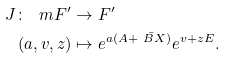Convert formula to latex. <formula><loc_0><loc_0><loc_500><loc_500>J \colon \ m F ^ { \prime } & \to F ^ { \prime } \\ ( a , v , z ) & \mapsto e ^ { a ( A + \bar { \ B X } ) } e ^ { v + z E } .</formula> 